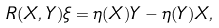<formula> <loc_0><loc_0><loc_500><loc_500>R ( X , Y ) \xi = \eta ( X ) Y - \eta ( Y ) X ,</formula> 